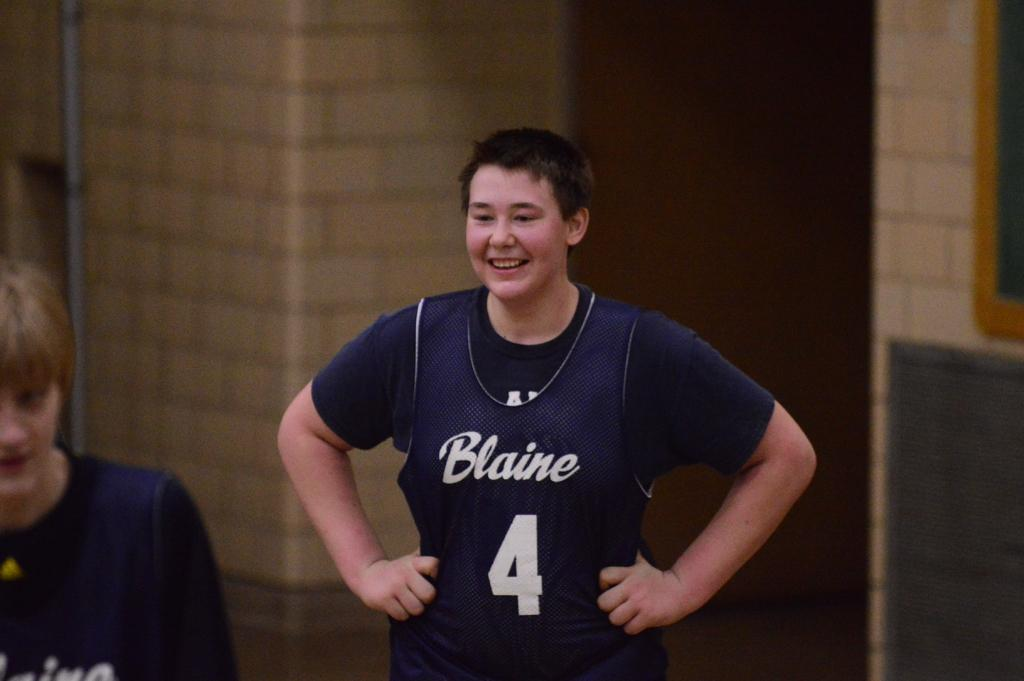<image>
Describe the image concisely. A young boy stands with his hands on his hips with a black tee shirt and purple jersey that says Blaine and the number 4 on it. 